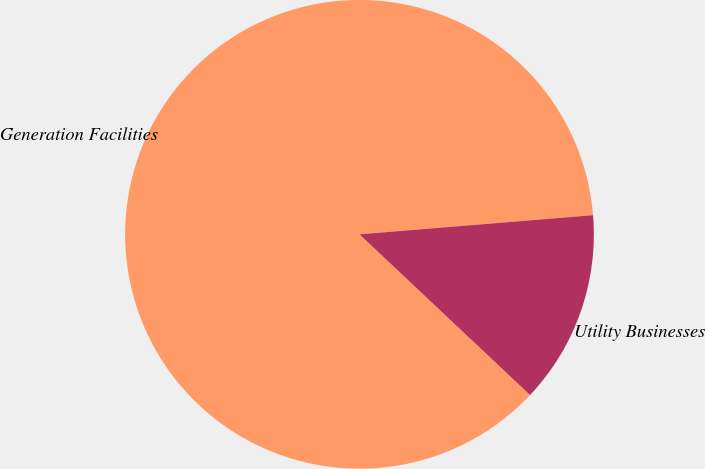<chart> <loc_0><loc_0><loc_500><loc_500><pie_chart><fcel>Generation Facilities<fcel>Utility Businesses<nl><fcel>86.67%<fcel>13.33%<nl></chart> 